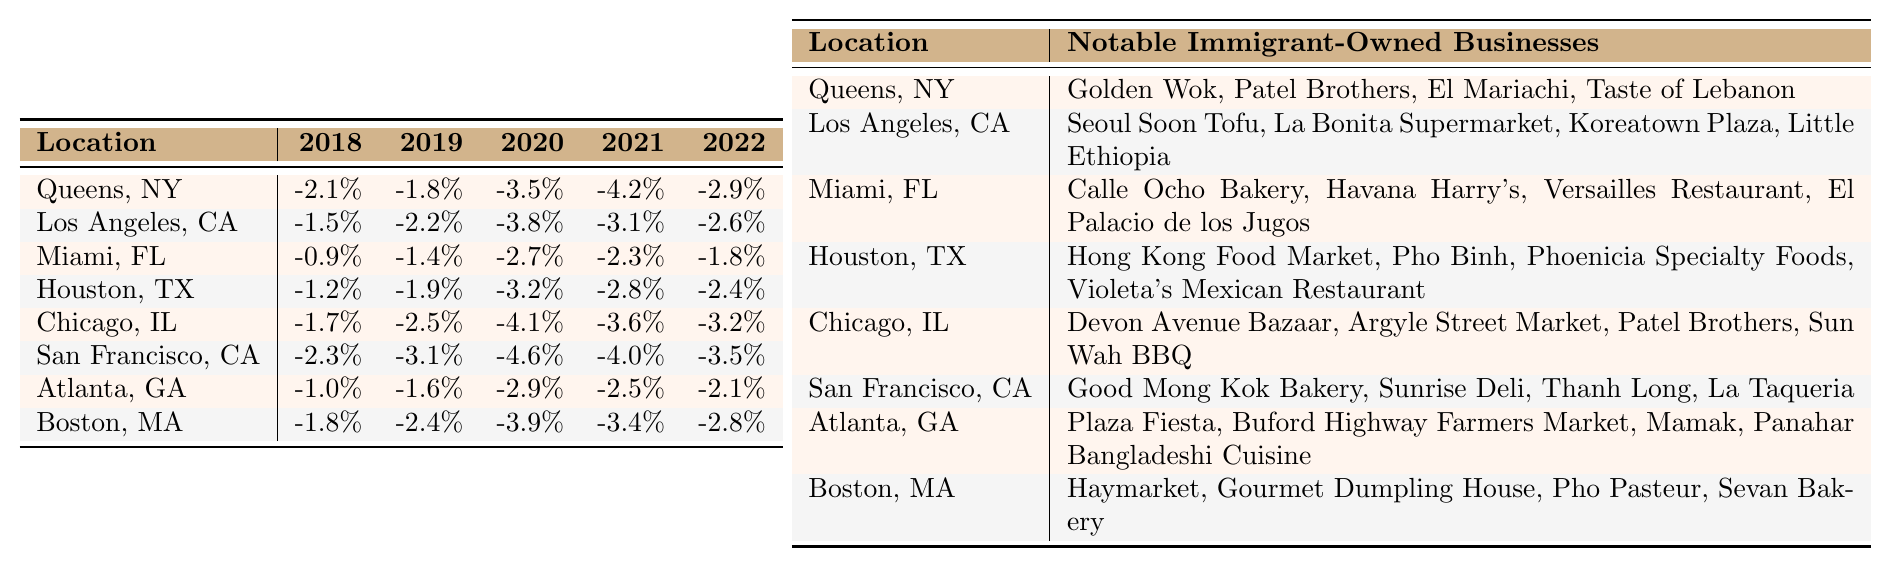What is the rental income change in Miami, FL for 2021? In the table, under Miami, FL, the rental income change for 2021 is listed as -2.3%.
Answer: -2.3% Which location had the highest decline in rental income change in 2020? By comparing the values for 2020 in the table, San Francisco, CA has the highest decline at -4.6%.
Answer: San Francisco, CA What is the average rental income change across all locations for the year 2019? To find the average for 2019, sum all the changes: (-1.8) + (-2.2) + (-1.4) + (-1.9) + (-2.5) + (-3.1) + (-1.6) + (-2.4) = -16.0%. Divide by 8 locations gives -16.0/8 = -2.0%.
Answer: -2.0% Does Atlanta, GA show a rental income change that is improving over the years? Analyzing the values for Atlanta, GA over the years 2018 to 2022: -1.0, -1.6, -2.9, -2.5, -2.1%. The values are fluctuating but the trend shows an improvement from -2.9% in 2020 to -2.1% in 2022, confirming an improvement.
Answer: Yes Which location shows the steepest rental income decline from 2019 to 2021? Check the rental income change for each location from 2019 to 2021. Calculate the difference for each: Queens, NY = -4.2 - (-1.8) = -2.4; Los Angeles, CA = -3.1 - (-2.2) = -0.9; ... San Francisco, CA = -4.0 - (-3.1) = -0.9. Queens, NY has the steepest decline of -2.4%.
Answer: Queens, NY Are there more locations with a rental income change less than -3% in 2022 than those with a change greater than -3%? In 2022, -3% or lower locations are Los Angeles, CA (-2.6), Miami, FL (-1.8), Houston, TX (-2.4), Chicago, IL (-3.2), San Francisco, CA (-3.5), Atlanta, GA (-2.1), Boston, MA (-2.8). This totals 7 and those above -3% are 1 (Queens, NY). Thus, there are more locations below -3%.
Answer: Yes What is the total rental income change for Houston, TX over the five years? Sum the entries for Houston, TX: -1.2 + (-1.9) + (-3.2) + (-2.8) + (-2.4) = -11.5%.
Answer: -11.5% Which two locations had the closest rental income change for the year 2022? Look at the 2022 values: Los Angeles, CA (-2.6), Miami, FL (-1.8), Houston, TX (-2.4), Chicago, IL (-3.2), San Francisco, CA (-3.5), Atlanta, GA (-2.1), Boston, MA (-2.8). The closest values are Los Angeles, CA and Houston, TX with -2.6% and -2.4%, respectively.
Answer: Los Angeles, CA and Houston, TX In which year did Chicago, IL experience the highest rental income decline? In the table, the rental income changes over the years for Chicago, IL are: -1.7%, -2.5%, -4.1%, -3.6%, -3.2%. The highest decline is in 2020 with -4.1%.
Answer: 2020 Is there any year where all locations report a rental income decline above -3%? Review the years for all locations: No year shows all locations exceeding -3%, as there are declines below that threshold in each year.
Answer: No 